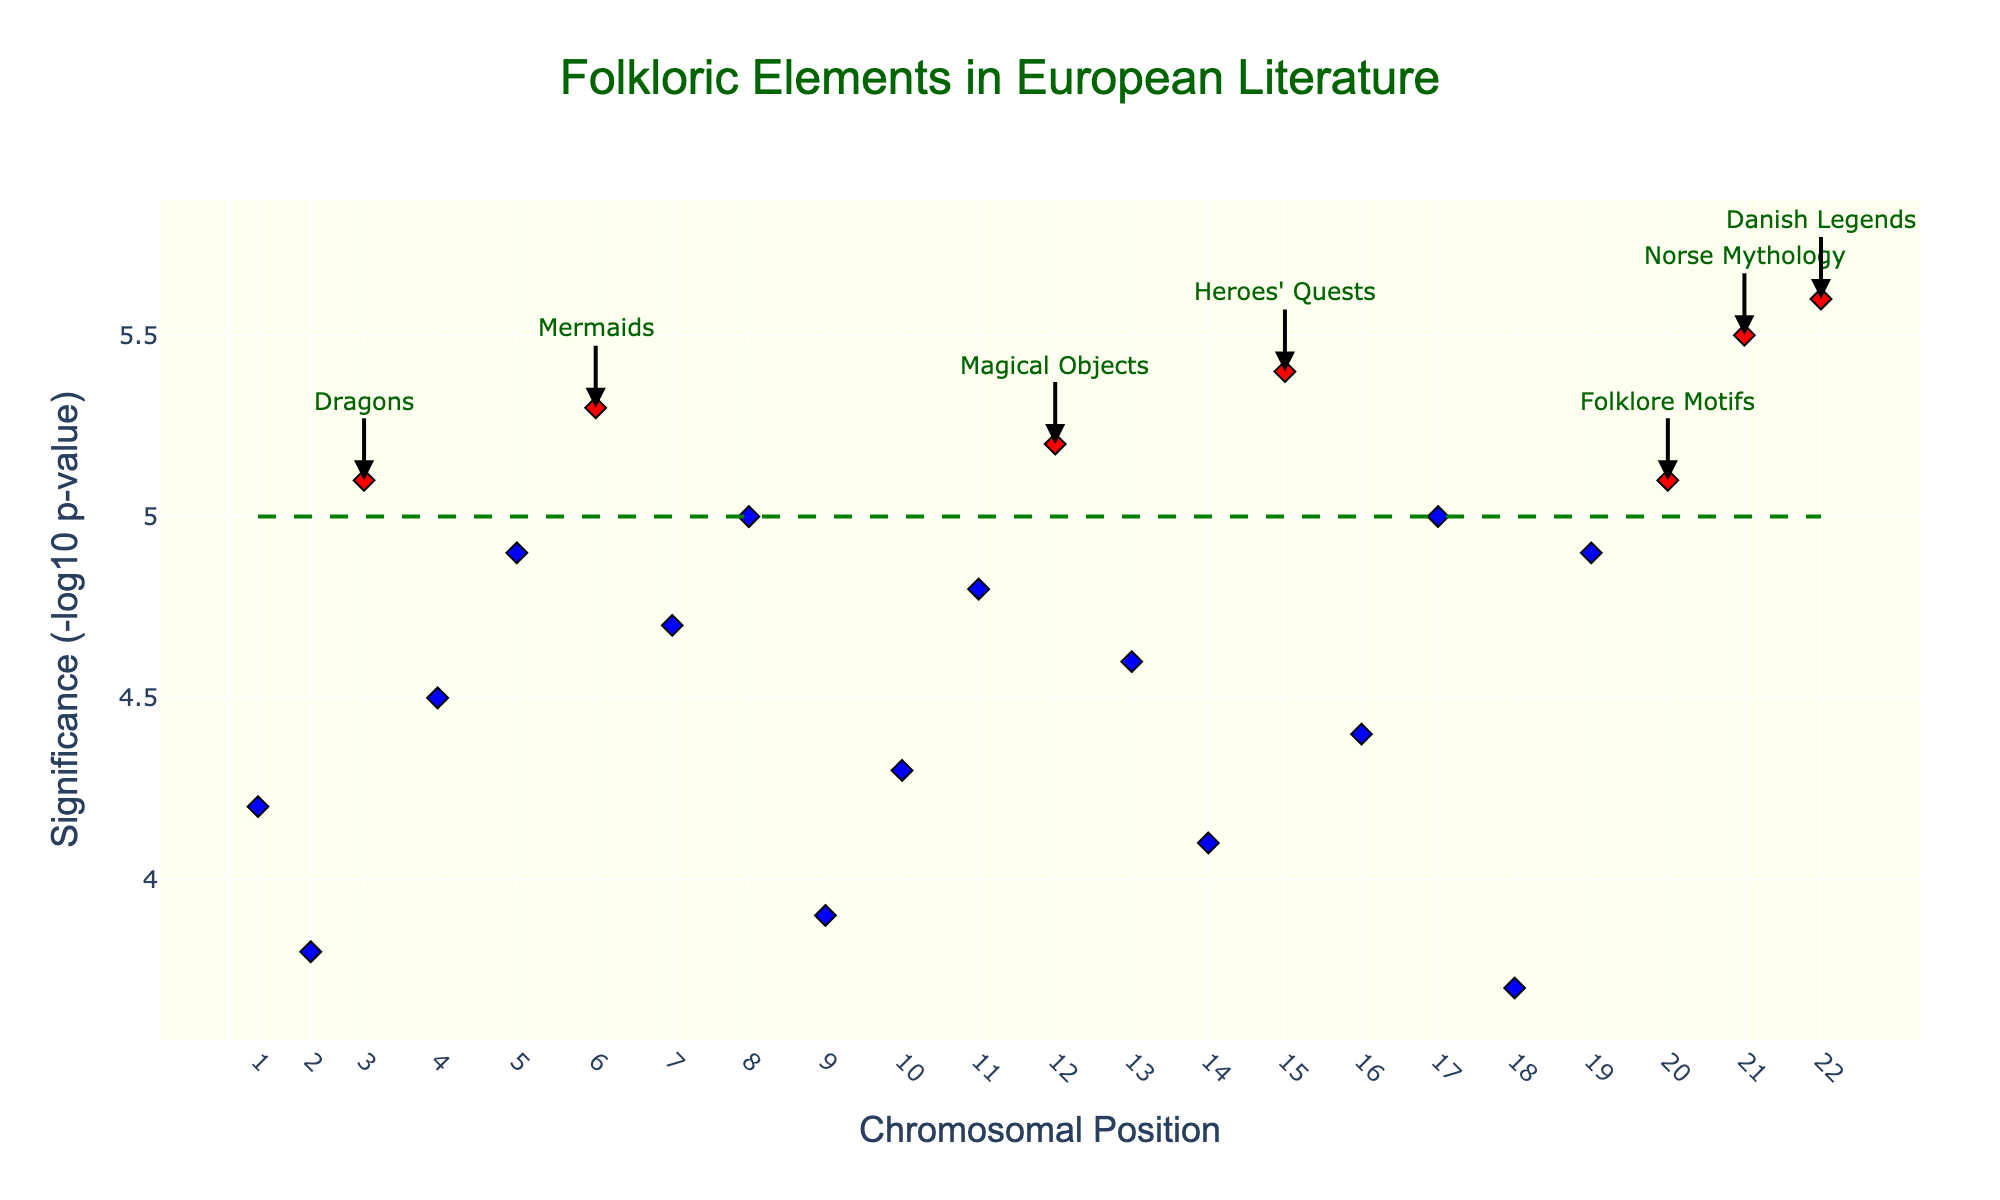What is the title of the plot? The title can be seen at the top of the plot. It reads "Folkloric Elements in European Literature."
Answer: Folkloric Elements in European Literature What axis represents the significance of folkloric elements? The y-axis represents the significance, which is labeled as "Significance (-log10 p-value)" in the figure.
Answer: y-axis How are elements with significance greater than 5.0 visually distinguished in the plot? Elements with significance greater than 5.0 are marked in red, while others are marked in blue.
Answer: color How many folkloric elements have a significance greater than 5.0? To find this, count the number of red markers in the plot. There are 9 red markers.
Answer: 9 Which folkloric element has the highest significance? Look for the point that is the highest on the y-axis. The annotation near this point reads "Danish Legends" with a significance of 5.6.
Answer: Danish Legends What is the significance threshold indicated by the horizontal line in the plot? There is a horizontal dashed green line; it is labeled at the significance level of 5.0.
Answer: 5.0 Which chromosomes have only one data point represented in the plot? By observing the x-axis and the positions of the points, chromosomes 2, 3, 4, and several others only have one point each.
Answer: chromosomes 2, 3, 4, etc What element is found at the chromosomal position of 123000? Find the point located at position 123000 on the x-axis and check the hover text or annotation. This is "Enchanted Forests."
Answer: Enchanted Forests Compare the significance of "Mermaids" and "Giants". Which is greater? "Mermaids" has a significance of 5.3, while "Giants" has a significance of 4.3. Therefore, "Mermaids" is more significant.
Answer: Mermaids Which three elements have the highest significance values and what are their values? Observe the plot's annotations and heights. "Danish Legends" (5.6), "Norse Mythology" (5.5), and "Heroes' Quests" (5.4) are the three highest.
Answer: Danish Legends (5.6), Norse Mythology (5.5), Heroes' Quests (5.4) 